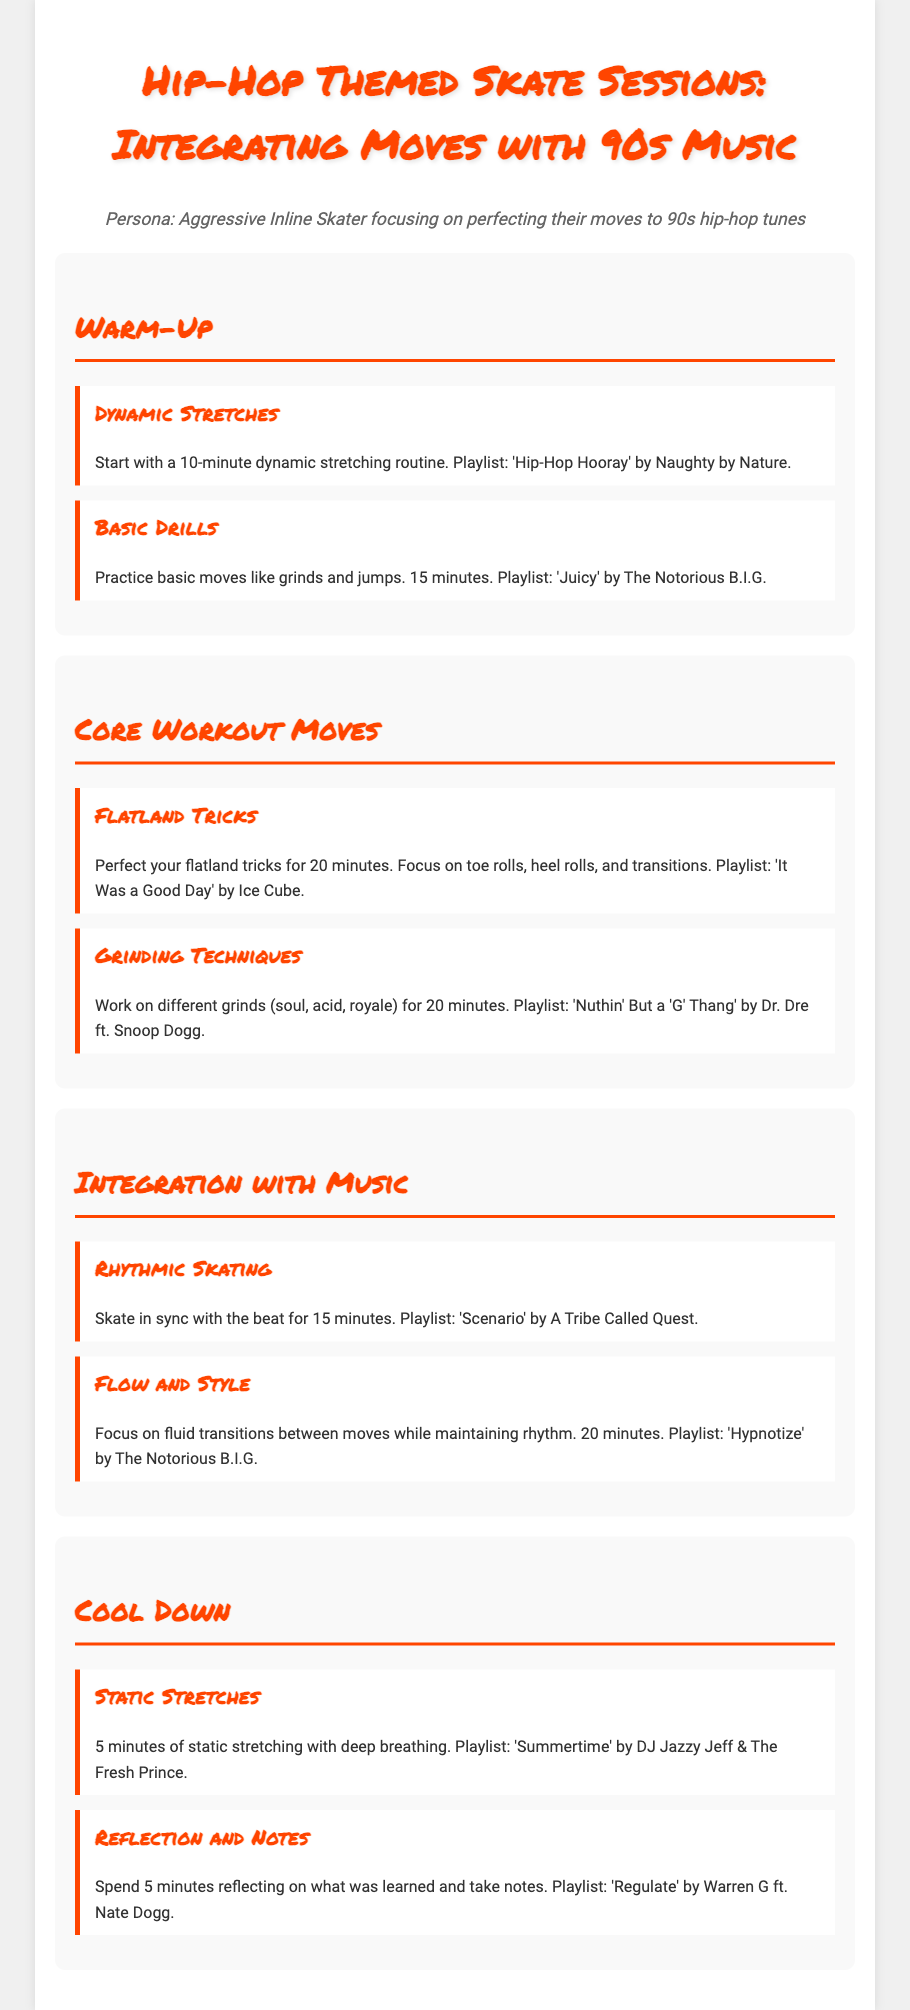What is the title of the workout plan? The title is displayed prominently at the top of the document, summarizing the theme of the sessions.
Answer: Hip-Hop Themed Skate Sessions: Integrating Moves with 90s Music How long should the dynamic stretching routine last? The warm-up section specifies the duration for each warm-up activity, including dynamic stretches.
Answer: 10 minutes What song is suggested for practicing basic moves? The document lists playlists associated with each workout activity, particularly for the basic drills section.
Answer: Juicy by The Notorious B.I.G What type of tricks should be perfected for 20 minutes? The core workout moves section outlines specific tricks to focus on during this time frame.
Answer: Flatland tricks Which activities are included in the cool down section? The cool down section includes two specific activities, both followed by a music track for relaxation.
Answer: Static stretches and Reflection and Notes What is the focus of the 'Flow and Style' move? The description indicates the skillset that should be emphasized during this particular skating session.
Answer: Fluid transitions between moves How long should rhythmic skating be practiced? The duration is explicitly mentioned in the integration with music section for rhythmic skating.
Answer: 15 minutes What playlist is recommended for the grinding techniques? Each move is associated with a specific song; this one is listed in the grinding techniques section.
Answer: Nuthin' But a 'G' Thang by Dr. Dre ft. Snoop Dogg What kind of stretching is performed at the end of the session? The cool down section describes the type of stretching recommended after workouts.
Answer: Static stretching 